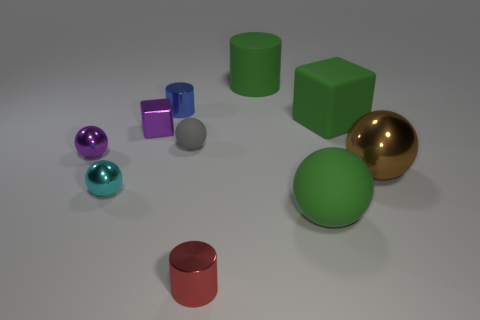Subtract all brown spheres. How many spheres are left? 4 Subtract all big brown spheres. How many spheres are left? 4 Subtract all gray balls. Subtract all purple cubes. How many balls are left? 4 Subtract all cubes. How many objects are left? 8 Subtract all red metallic cylinders. Subtract all tiny gray objects. How many objects are left? 8 Add 3 big matte cylinders. How many big matte cylinders are left? 4 Add 8 large red metal objects. How many large red metal objects exist? 8 Subtract 0 red blocks. How many objects are left? 10 